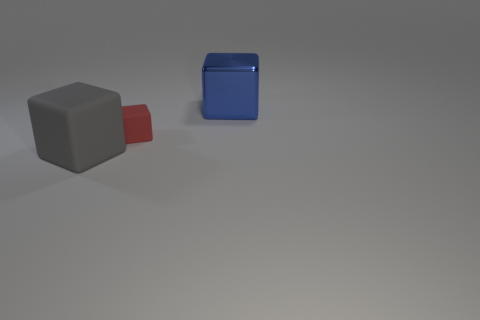Are there any other things that are the same size as the red matte cube?
Offer a terse response. No. Is there any other thing that has the same material as the big blue object?
Ensure brevity in your answer.  No. There is a big cube that is in front of the shiny cube; is there a gray cube that is left of it?
Your answer should be very brief. No. How many tiny green rubber cylinders are there?
Keep it short and to the point. 0. The cube that is both on the right side of the gray object and left of the blue cube is what color?
Your response must be concise. Red. The other red object that is the same shape as the large shiny thing is what size?
Offer a very short reply. Small. How many gray matte blocks are the same size as the gray rubber thing?
Your answer should be very brief. 0. What is the tiny red block made of?
Keep it short and to the point. Rubber. There is a metal object; are there any rubber things in front of it?
Provide a succinct answer. Yes. What is the size of the red block that is the same material as the gray object?
Offer a very short reply. Small. 